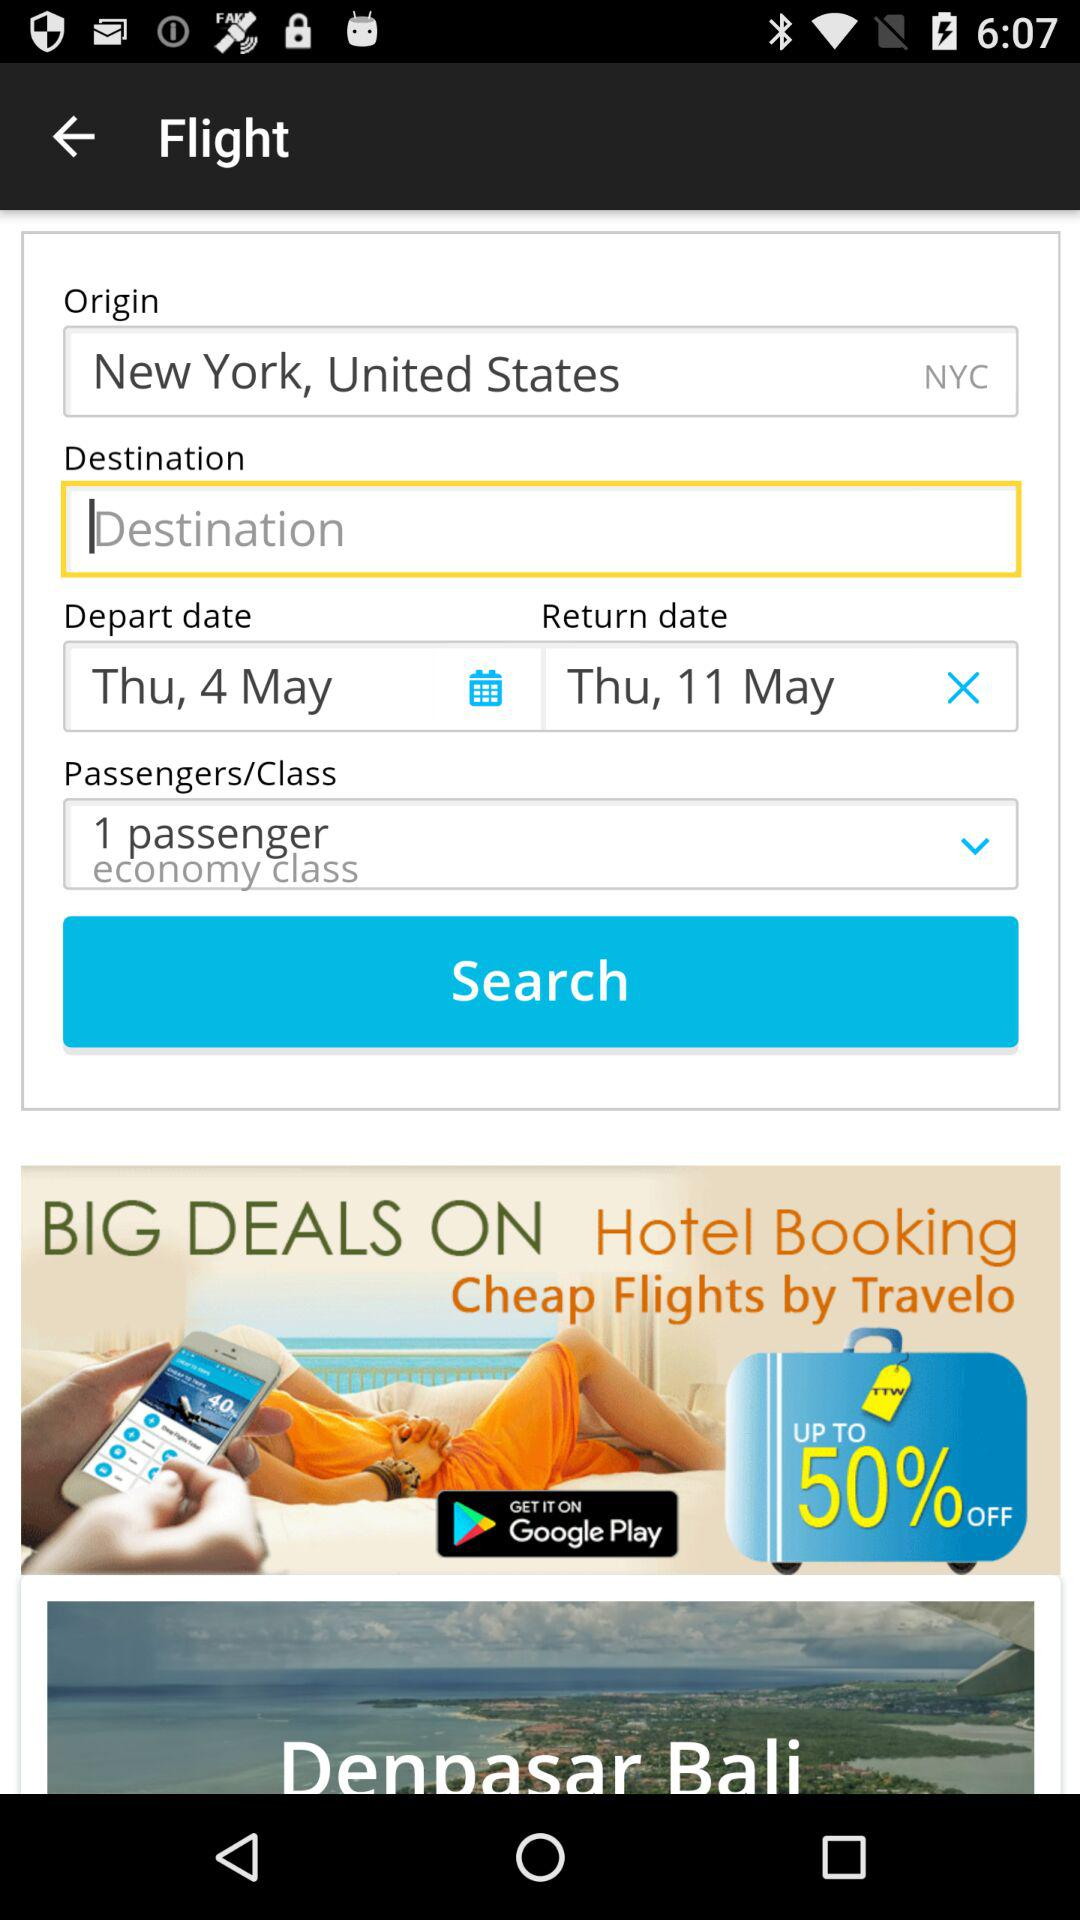How many passengers are there in this booking?
Answer the question using a single word or phrase. 1 